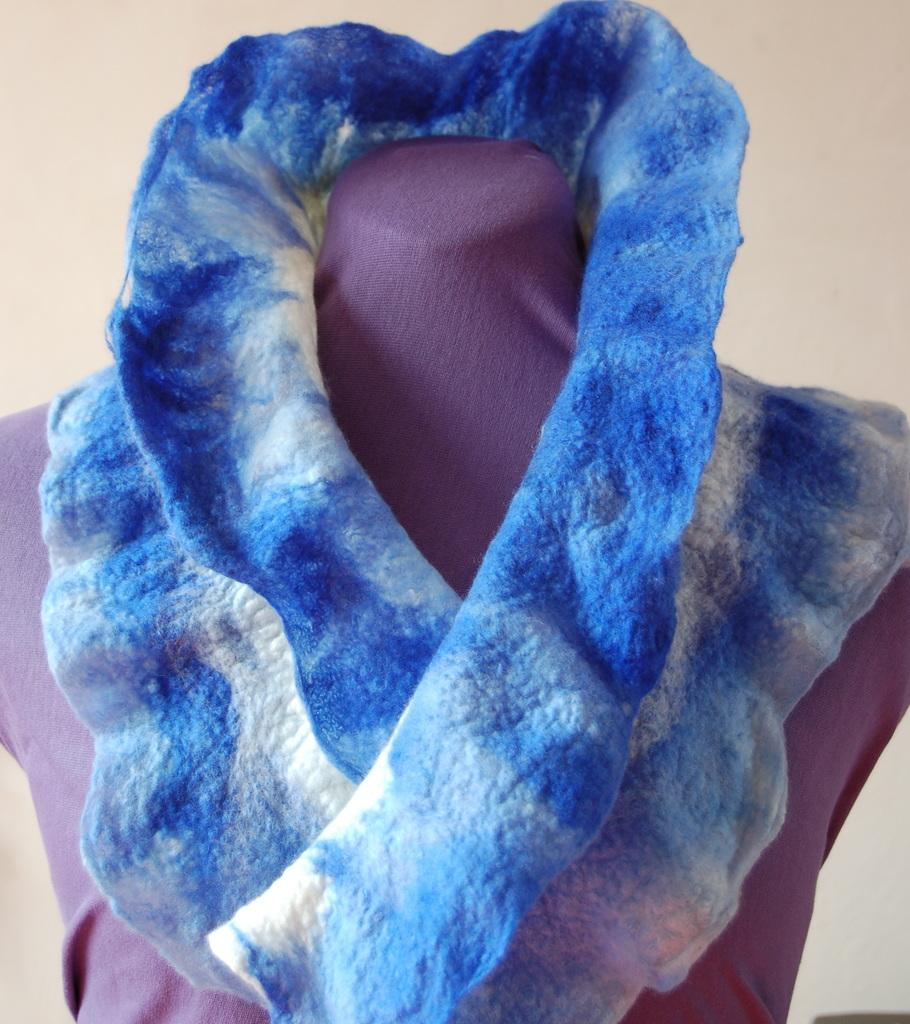What is placed on the statue in the image? There is a dress on a statue in the image. What color is the background of the image? The background of the image is white. Can you see any robins in the image? There are no robins present in the image. What type of bean is being grown in the image? There is no bean being grown in the image. 